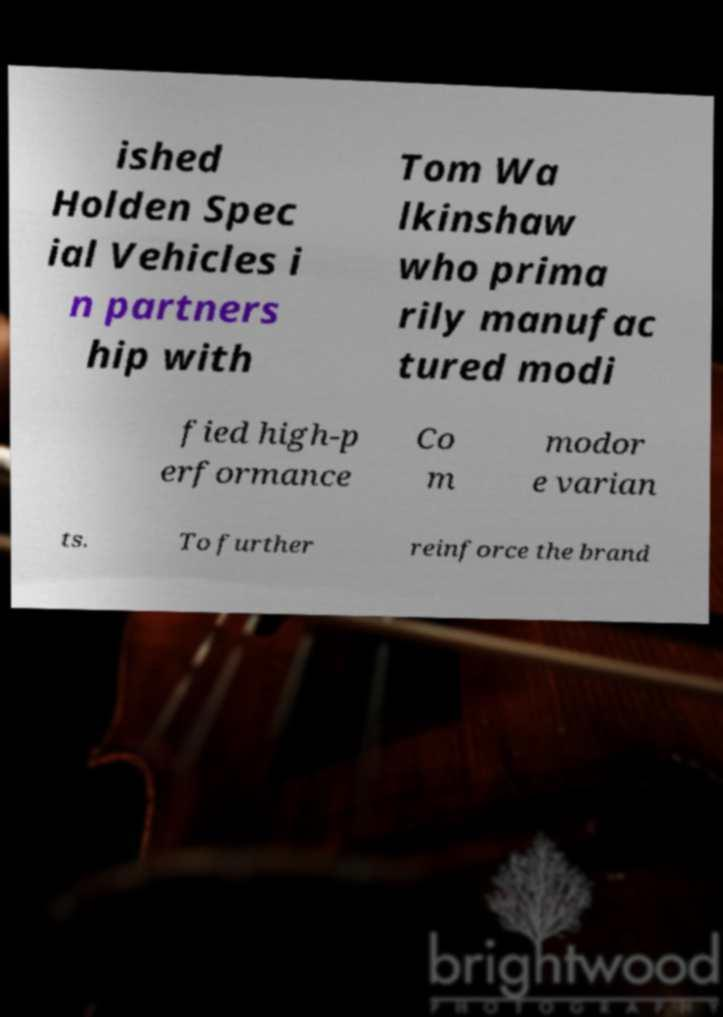Please read and relay the text visible in this image. What does it say? ished Holden Spec ial Vehicles i n partners hip with Tom Wa lkinshaw who prima rily manufac tured modi fied high-p erformance Co m modor e varian ts. To further reinforce the brand 